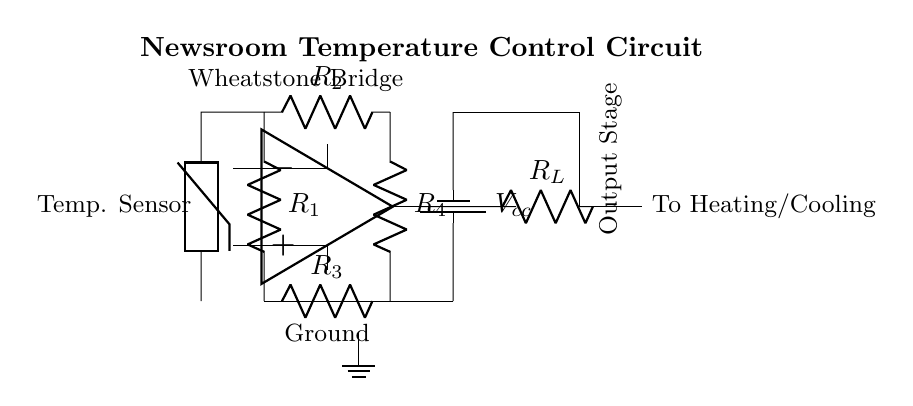What type of temperature sensor is used in this circuit? The circuit shows a thermistor, which is commonly used for temperature measurement due to its sensitivity to temperature changes.
Answer: Thermistor What does the Wheatstone bridge do in this circuit? The Wheatstone bridge compares the resistance of the thermistor with the resistors R1, R2, R3, and R4, allowing for accurate measurement of the temperature based on the changes in resistance.
Answer: Measures temperature What is the purpose of the operational amplifier in this circuit? The operational amplifier amplifies the voltage difference coming from the Wheatstone bridge to drive the output stage for controlling heating or cooling systems based on temperature.
Answer: Amplification How many resistors are present in the Wheatstone bridge? The diagram indicates four resistors, R1, R2, R3, and R4, essential for forming the bridge and measuring temperature accurately.
Answer: Four What type of transistor is shown in the output stage? In the output stage, a PNP transistor is depicted, which is typically used for switching and controlling larger loads in response to the amplified output.
Answer: PNP What is the main output component connected to the operational amplifier? The load resistor R_L is connected after the operational amplifier, providing the necessary pathway for current to control heating or cooling elements.
Answer: Load resistor 